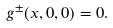Convert formula to latex. <formula><loc_0><loc_0><loc_500><loc_500>g ^ { \pm } ( x , 0 , 0 ) = 0 .</formula> 